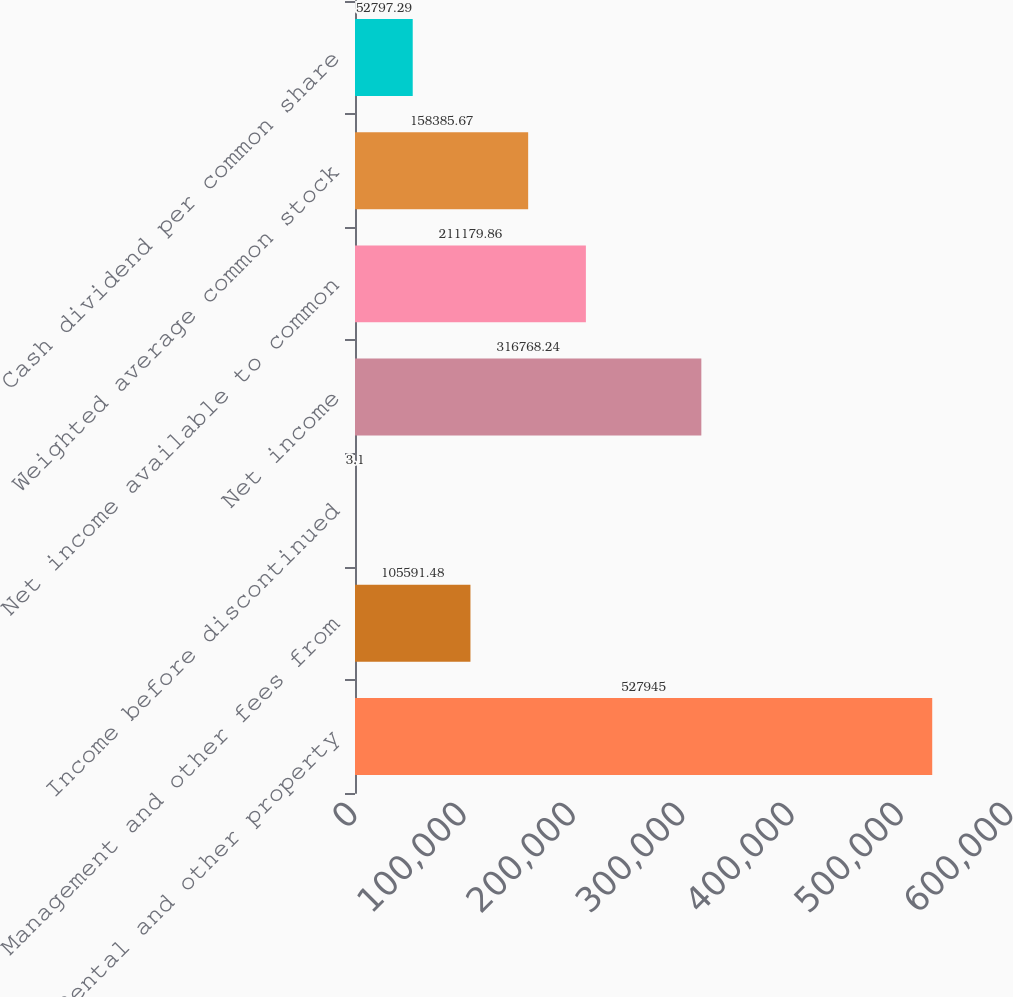Convert chart. <chart><loc_0><loc_0><loc_500><loc_500><bar_chart><fcel>Rental and other property<fcel>Management and other fees from<fcel>Income before discontinued<fcel>Net income<fcel>Net income available to common<fcel>Weighted average common stock<fcel>Cash dividend per common share<nl><fcel>527945<fcel>105591<fcel>3.1<fcel>316768<fcel>211180<fcel>158386<fcel>52797.3<nl></chart> 